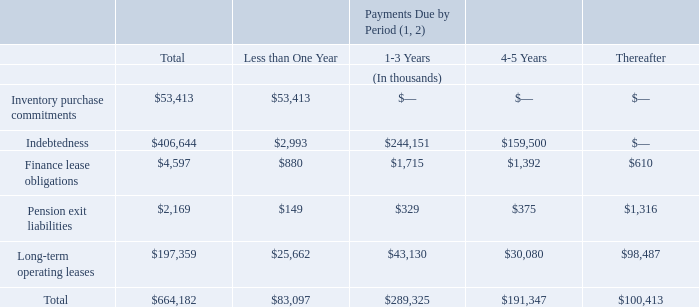Commitments and Significant Contractual Obligations
The following table summarizes our contractual obligations and commercial commitments at December 27, 2019:
(1) Interest on our various outstanding debt instruments is included in the above table, except for our Term Loan and ABL, which have floating interest rates. At December 27, 2019, we had borrowings of $238.1 million under our Term Loan and zero under our ABL. During the fiscal year ended December 27, 2019, the weighted average interest rate on our Term Loan was approximately 5.8% and we incurred interest expense of approximately $13.9 million. During the fiscal year ended December 27, 2019, the weighted average interest rate on our ABL borrowings was approximately 3.7% and we incurred interest expense of approximately $1.6 million. See Note 9 “Debt Obligations” to our consolidated financial statements for further information on our debt instruments.
(2) The table above excludes cash to be paid for income taxes, $14.7 million of total contingent earn-out liabilities related to certain acquisitions as of December 27, 2019 and approximately $5.3 million of lease payments related to long-term leases for several vehicles and a distribution and processing facility that do not commence until fiscal 2020.
We had outstanding letters of credit of approximately $16.6 million and $15.8 million at December 27, 2019 and December 28, 2018, respectively. Substantially all of our assets are pledged as collateral to secure our borrowings under our credit facilities.
What is the total Inventory purchase commitments for all periods?
Answer scale should be: thousand. $53,413. What is the total Indebtedness for all periods?
Answer scale should be: thousand. $406,644. At December 27, 2019, what is the amount of borrowings under our Term Loan? $238.1 million. What is the difference in the total Indebtedness and total Inventory purchase commitments for all periods?
Answer scale should be: thousand. 406,644-53,413
Answer: 353231. What is the percentage constitution of total inventory purchase commitments among the total contractual obligations?
Answer scale should be: percent. 53,413/664,182
Answer: 8.04. Which component of contractual obligation has the highest total value? 406,644> 197,359> 53,413> 4,597> 2,169
Answer: indebtedness. 